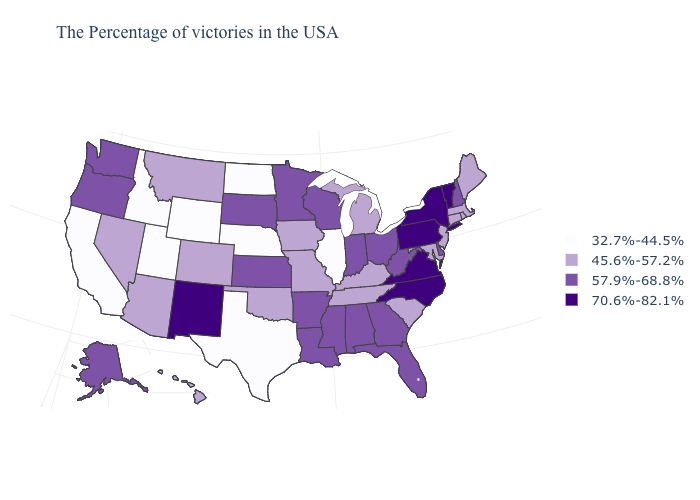What is the highest value in the USA?
Be succinct. 70.6%-82.1%. Among the states that border West Virginia , which have the lowest value?
Short answer required. Maryland, Kentucky. What is the value of Montana?
Short answer required. 45.6%-57.2%. Does Vermont have the highest value in the Northeast?
Quick response, please. Yes. Does Minnesota have the highest value in the USA?
Keep it brief. No. Among the states that border New York , which have the highest value?
Quick response, please. Vermont, Pennsylvania. How many symbols are there in the legend?
Concise answer only. 4. Does Utah have the lowest value in the USA?
Quick response, please. Yes. Which states have the lowest value in the Northeast?
Concise answer only. Maine, Massachusetts, Rhode Island, Connecticut, New Jersey. Does the map have missing data?
Write a very short answer. No. Which states hav the highest value in the South?
Be succinct. Virginia, North Carolina. Among the states that border Ohio , does Pennsylvania have the highest value?
Keep it brief. Yes. What is the value of Washington?
Answer briefly. 57.9%-68.8%. Name the states that have a value in the range 70.6%-82.1%?
Concise answer only. Vermont, New York, Pennsylvania, Virginia, North Carolina, New Mexico. What is the value of Texas?
Concise answer only. 32.7%-44.5%. 